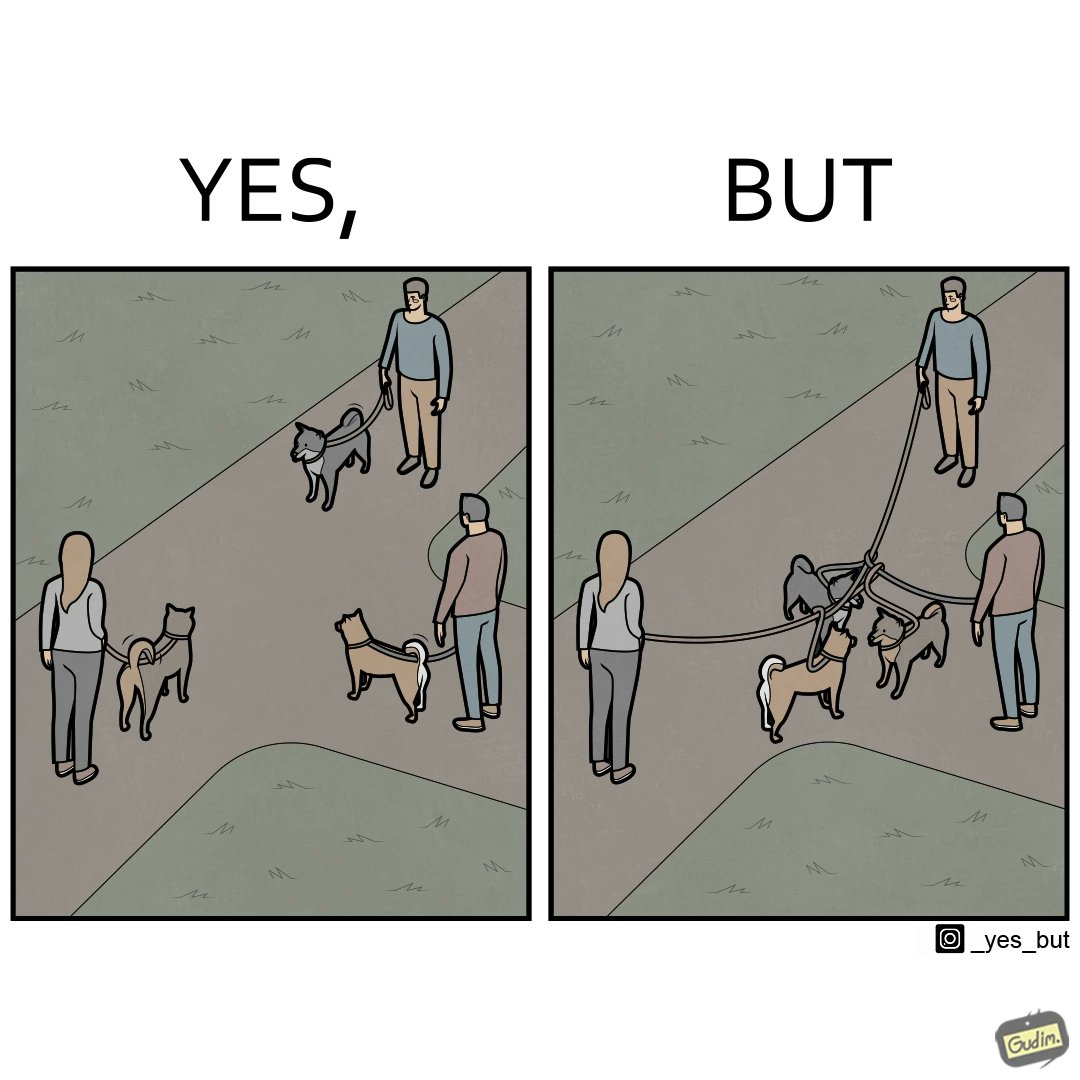What do you see in each half of this image? In the left part of the image: three different dog owners with their dog walking in some park In the right part of the image: three different dog owners with their dog walking in some park with their dogs mingled 